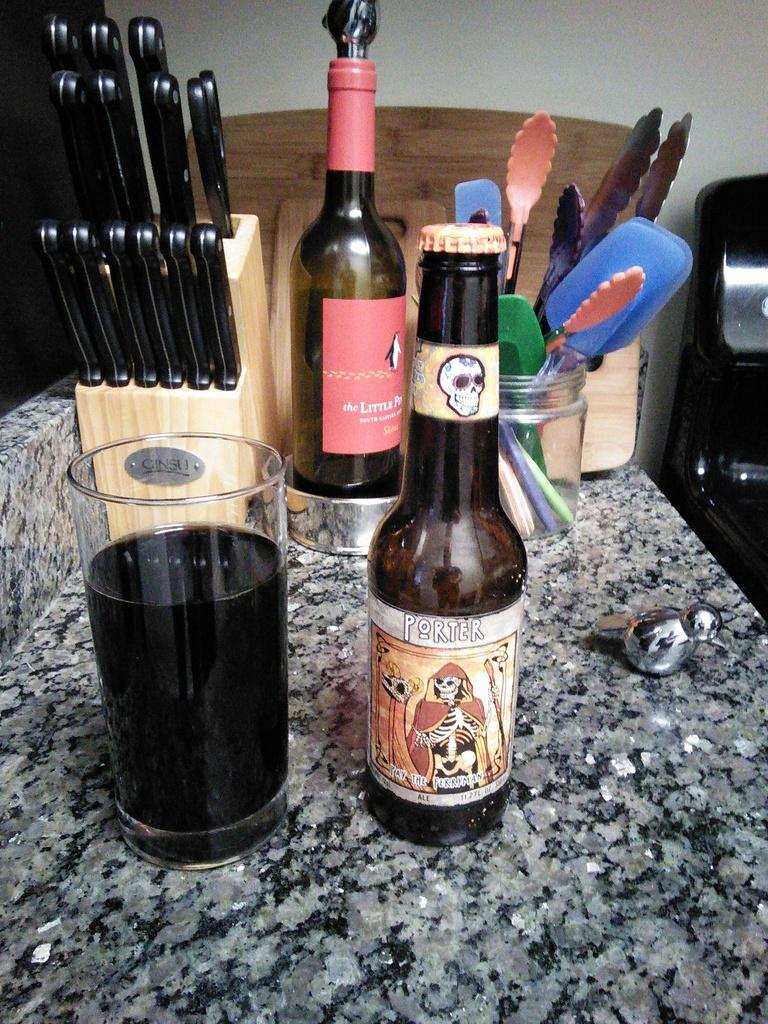<image>
Summarize the visual content of the image. Beer bottle named Porter next to a cup of beer. 